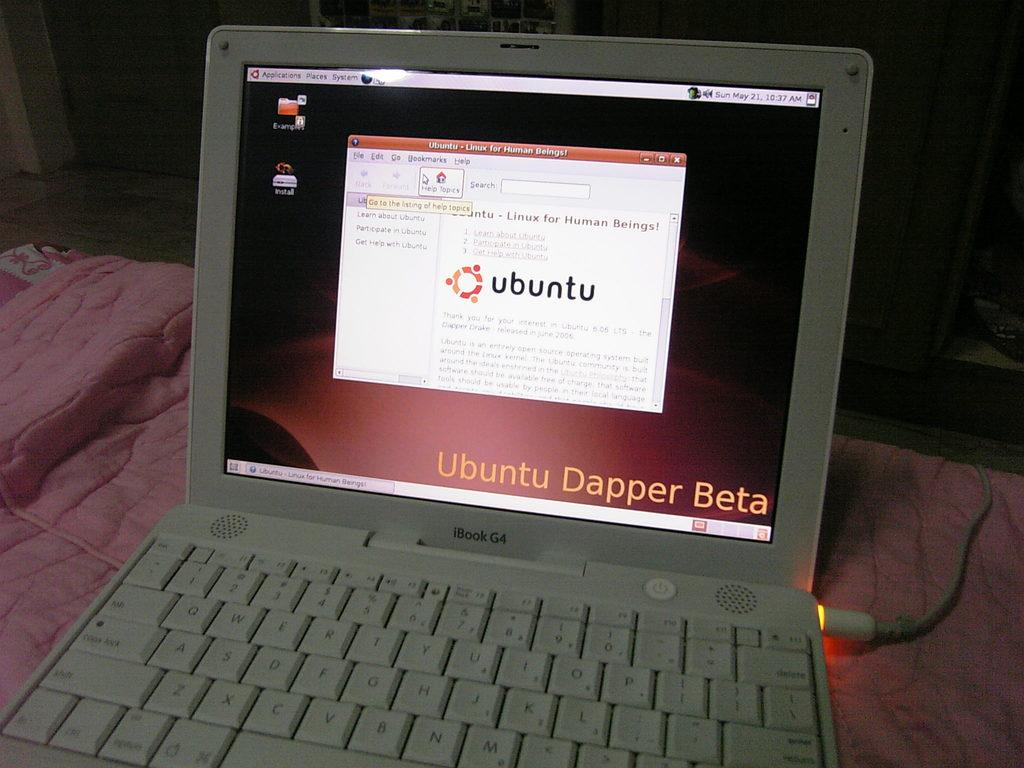<image>
Create a compact narrative representing the image presented. an 'ibook g4'   with a page that says 'ubuntu' on the screen 